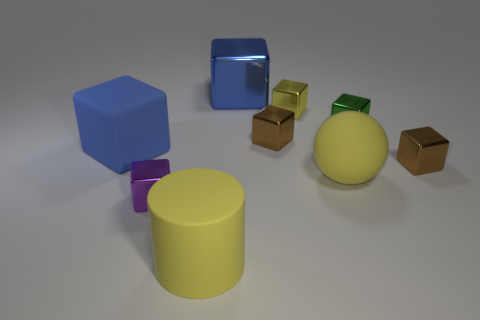Subtract 3 blocks. How many blocks are left? 4 Subtract all green blocks. How many blocks are left? 6 Subtract all blue blocks. How many blocks are left? 5 Subtract all gray cubes. Subtract all red cylinders. How many cubes are left? 7 Add 1 tiny green matte cylinders. How many objects exist? 10 Subtract all blocks. How many objects are left? 2 Add 2 tiny yellow cubes. How many tiny yellow cubes are left? 3 Add 2 big brown metal cylinders. How many big brown metal cylinders exist? 2 Subtract 1 yellow spheres. How many objects are left? 8 Subtract all yellow matte spheres. Subtract all small green shiny cubes. How many objects are left? 7 